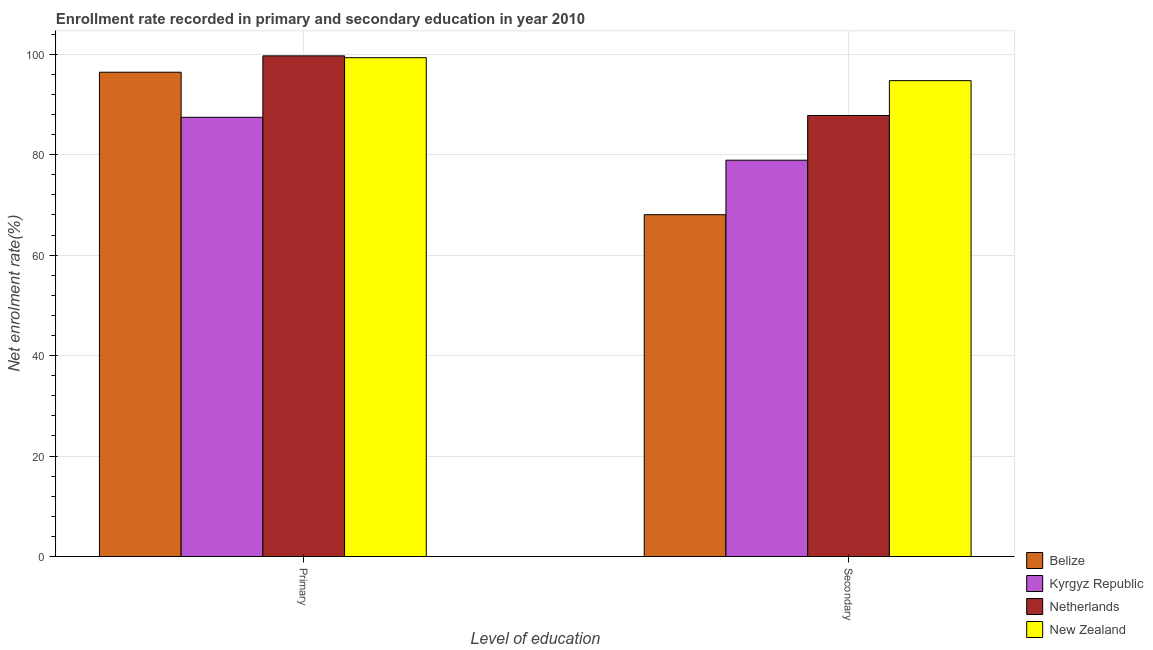Are the number of bars per tick equal to the number of legend labels?
Offer a terse response. Yes. Are the number of bars on each tick of the X-axis equal?
Provide a short and direct response. Yes. How many bars are there on the 2nd tick from the left?
Provide a short and direct response. 4. How many bars are there on the 1st tick from the right?
Ensure brevity in your answer.  4. What is the label of the 1st group of bars from the left?
Your answer should be compact. Primary. What is the enrollment rate in primary education in Kyrgyz Republic?
Your answer should be very brief. 87.45. Across all countries, what is the maximum enrollment rate in secondary education?
Your response must be concise. 94.75. Across all countries, what is the minimum enrollment rate in secondary education?
Provide a succinct answer. 68.05. In which country was the enrollment rate in primary education maximum?
Give a very brief answer. Netherlands. In which country was the enrollment rate in primary education minimum?
Your answer should be compact. Kyrgyz Republic. What is the total enrollment rate in primary education in the graph?
Offer a very short reply. 382.86. What is the difference between the enrollment rate in secondary education in New Zealand and that in Netherlands?
Offer a terse response. 6.94. What is the difference between the enrollment rate in primary education in Kyrgyz Republic and the enrollment rate in secondary education in Belize?
Ensure brevity in your answer.  19.4. What is the average enrollment rate in primary education per country?
Give a very brief answer. 95.71. What is the difference between the enrollment rate in primary education and enrollment rate in secondary education in Belize?
Provide a succinct answer. 28.37. In how many countries, is the enrollment rate in secondary education greater than 96 %?
Your response must be concise. 0. What is the ratio of the enrollment rate in secondary education in Kyrgyz Republic to that in Belize?
Keep it short and to the point. 1.16. Is the enrollment rate in primary education in Kyrgyz Republic less than that in Netherlands?
Offer a terse response. Yes. What does the 4th bar from the left in Secondary represents?
Offer a terse response. New Zealand. What does the 4th bar from the right in Primary represents?
Make the answer very short. Belize. Are the values on the major ticks of Y-axis written in scientific E-notation?
Give a very brief answer. No. How many legend labels are there?
Your answer should be very brief. 4. What is the title of the graph?
Provide a succinct answer. Enrollment rate recorded in primary and secondary education in year 2010. What is the label or title of the X-axis?
Provide a short and direct response. Level of education. What is the label or title of the Y-axis?
Your answer should be very brief. Net enrolment rate(%). What is the Net enrolment rate(%) of Belize in Primary?
Your answer should be compact. 96.42. What is the Net enrolment rate(%) of Kyrgyz Republic in Primary?
Provide a succinct answer. 87.45. What is the Net enrolment rate(%) of Netherlands in Primary?
Provide a succinct answer. 99.68. What is the Net enrolment rate(%) of New Zealand in Primary?
Offer a terse response. 99.31. What is the Net enrolment rate(%) of Belize in Secondary?
Provide a short and direct response. 68.05. What is the Net enrolment rate(%) in Kyrgyz Republic in Secondary?
Give a very brief answer. 78.91. What is the Net enrolment rate(%) in Netherlands in Secondary?
Ensure brevity in your answer.  87.8. What is the Net enrolment rate(%) of New Zealand in Secondary?
Offer a very short reply. 94.75. Across all Level of education, what is the maximum Net enrolment rate(%) in Belize?
Provide a succinct answer. 96.42. Across all Level of education, what is the maximum Net enrolment rate(%) in Kyrgyz Republic?
Your answer should be very brief. 87.45. Across all Level of education, what is the maximum Net enrolment rate(%) of Netherlands?
Offer a very short reply. 99.68. Across all Level of education, what is the maximum Net enrolment rate(%) of New Zealand?
Your answer should be compact. 99.31. Across all Level of education, what is the minimum Net enrolment rate(%) of Belize?
Ensure brevity in your answer.  68.05. Across all Level of education, what is the minimum Net enrolment rate(%) of Kyrgyz Republic?
Provide a succinct answer. 78.91. Across all Level of education, what is the minimum Net enrolment rate(%) of Netherlands?
Offer a very short reply. 87.8. Across all Level of education, what is the minimum Net enrolment rate(%) in New Zealand?
Offer a very short reply. 94.75. What is the total Net enrolment rate(%) of Belize in the graph?
Provide a short and direct response. 164.47. What is the total Net enrolment rate(%) in Kyrgyz Republic in the graph?
Ensure brevity in your answer.  166.35. What is the total Net enrolment rate(%) in Netherlands in the graph?
Your answer should be compact. 187.48. What is the total Net enrolment rate(%) of New Zealand in the graph?
Provide a succinct answer. 194.06. What is the difference between the Net enrolment rate(%) in Belize in Primary and that in Secondary?
Keep it short and to the point. 28.37. What is the difference between the Net enrolment rate(%) of Kyrgyz Republic in Primary and that in Secondary?
Give a very brief answer. 8.54. What is the difference between the Net enrolment rate(%) in Netherlands in Primary and that in Secondary?
Your response must be concise. 11.87. What is the difference between the Net enrolment rate(%) in New Zealand in Primary and that in Secondary?
Your answer should be compact. 4.57. What is the difference between the Net enrolment rate(%) of Belize in Primary and the Net enrolment rate(%) of Kyrgyz Republic in Secondary?
Give a very brief answer. 17.51. What is the difference between the Net enrolment rate(%) of Belize in Primary and the Net enrolment rate(%) of Netherlands in Secondary?
Provide a succinct answer. 8.62. What is the difference between the Net enrolment rate(%) in Belize in Primary and the Net enrolment rate(%) in New Zealand in Secondary?
Provide a short and direct response. 1.67. What is the difference between the Net enrolment rate(%) of Kyrgyz Republic in Primary and the Net enrolment rate(%) of Netherlands in Secondary?
Give a very brief answer. -0.36. What is the difference between the Net enrolment rate(%) of Kyrgyz Republic in Primary and the Net enrolment rate(%) of New Zealand in Secondary?
Your answer should be very brief. -7.3. What is the difference between the Net enrolment rate(%) in Netherlands in Primary and the Net enrolment rate(%) in New Zealand in Secondary?
Offer a terse response. 4.93. What is the average Net enrolment rate(%) in Belize per Level of education?
Make the answer very short. 82.24. What is the average Net enrolment rate(%) of Kyrgyz Republic per Level of education?
Keep it short and to the point. 83.18. What is the average Net enrolment rate(%) in Netherlands per Level of education?
Provide a short and direct response. 93.74. What is the average Net enrolment rate(%) of New Zealand per Level of education?
Provide a succinct answer. 97.03. What is the difference between the Net enrolment rate(%) of Belize and Net enrolment rate(%) of Kyrgyz Republic in Primary?
Provide a short and direct response. 8.97. What is the difference between the Net enrolment rate(%) in Belize and Net enrolment rate(%) in Netherlands in Primary?
Your response must be concise. -3.26. What is the difference between the Net enrolment rate(%) in Belize and Net enrolment rate(%) in New Zealand in Primary?
Ensure brevity in your answer.  -2.89. What is the difference between the Net enrolment rate(%) of Kyrgyz Republic and Net enrolment rate(%) of Netherlands in Primary?
Make the answer very short. -12.23. What is the difference between the Net enrolment rate(%) in Kyrgyz Republic and Net enrolment rate(%) in New Zealand in Primary?
Your answer should be very brief. -11.86. What is the difference between the Net enrolment rate(%) of Netherlands and Net enrolment rate(%) of New Zealand in Primary?
Your response must be concise. 0.37. What is the difference between the Net enrolment rate(%) of Belize and Net enrolment rate(%) of Kyrgyz Republic in Secondary?
Ensure brevity in your answer.  -10.85. What is the difference between the Net enrolment rate(%) of Belize and Net enrolment rate(%) of Netherlands in Secondary?
Offer a terse response. -19.75. What is the difference between the Net enrolment rate(%) in Belize and Net enrolment rate(%) in New Zealand in Secondary?
Ensure brevity in your answer.  -26.69. What is the difference between the Net enrolment rate(%) of Kyrgyz Republic and Net enrolment rate(%) of Netherlands in Secondary?
Make the answer very short. -8.9. What is the difference between the Net enrolment rate(%) of Kyrgyz Republic and Net enrolment rate(%) of New Zealand in Secondary?
Your response must be concise. -15.84. What is the difference between the Net enrolment rate(%) of Netherlands and Net enrolment rate(%) of New Zealand in Secondary?
Ensure brevity in your answer.  -6.94. What is the ratio of the Net enrolment rate(%) of Belize in Primary to that in Secondary?
Your response must be concise. 1.42. What is the ratio of the Net enrolment rate(%) in Kyrgyz Republic in Primary to that in Secondary?
Ensure brevity in your answer.  1.11. What is the ratio of the Net enrolment rate(%) of Netherlands in Primary to that in Secondary?
Provide a short and direct response. 1.14. What is the ratio of the Net enrolment rate(%) in New Zealand in Primary to that in Secondary?
Your response must be concise. 1.05. What is the difference between the highest and the second highest Net enrolment rate(%) in Belize?
Provide a short and direct response. 28.37. What is the difference between the highest and the second highest Net enrolment rate(%) of Kyrgyz Republic?
Give a very brief answer. 8.54. What is the difference between the highest and the second highest Net enrolment rate(%) of Netherlands?
Make the answer very short. 11.87. What is the difference between the highest and the second highest Net enrolment rate(%) of New Zealand?
Your response must be concise. 4.57. What is the difference between the highest and the lowest Net enrolment rate(%) in Belize?
Ensure brevity in your answer.  28.37. What is the difference between the highest and the lowest Net enrolment rate(%) in Kyrgyz Republic?
Keep it short and to the point. 8.54. What is the difference between the highest and the lowest Net enrolment rate(%) of Netherlands?
Your answer should be compact. 11.87. What is the difference between the highest and the lowest Net enrolment rate(%) in New Zealand?
Your answer should be compact. 4.57. 